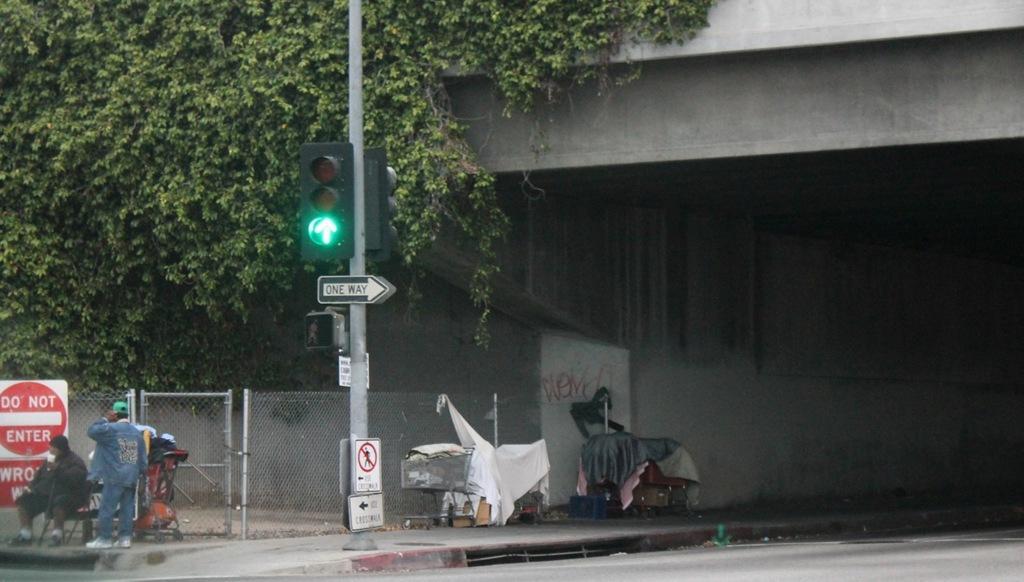How would you summarize this image in a sentence or two? In the picture we can see a bridge under it we can see a road and a path, on the path we can see two carts with some clothes on it and beside it, we can see a pole with traffic lights and behind it, we can see a fencing and near to it we can see some people standing and in the background we can see some creeper plants on the bridge. 